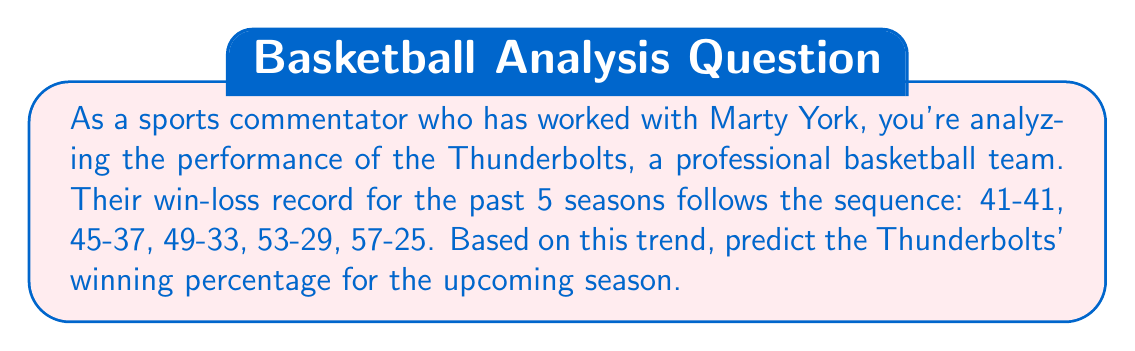Can you answer this question? Let's approach this step-by-step:

1) First, we need to identify the pattern in the number of wins:
   41, 45, 49, 53, 57

   We can see that the number of wins increases by 4 each season.

2) Following this pattern, we can predict that the next season will have 61 wins:
   57 + 4 = 61

3) In a standard NBA season, teams play 82 games. To calculate the winning percentage, we use the formula:

   $$ \text{Winning Percentage} = \frac{\text{Number of Wins}}{\text{Total Games}} \times 100\% $$

4) Plugging in our predicted 61 wins:

   $$ \text{Winning Percentage} = \frac{61}{82} \times 100\% $$

5) Simplifying:
   $$ \frac{61}{82} \approx 0.7439 $$

6) Converting to a percentage:
   $$ 0.7439 \times 100\% \approx 74.39\% $$

Therefore, based on the trend from the past five seasons, we can predict that the Thunderbolts will have a winning percentage of approximately 74.39% in the upcoming season.
Answer: 74.39% 